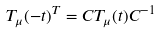Convert formula to latex. <formula><loc_0><loc_0><loc_500><loc_500>T _ { \mu } ( - t ) ^ { T } = C T _ { \mu } ( t ) C ^ { - 1 }</formula> 